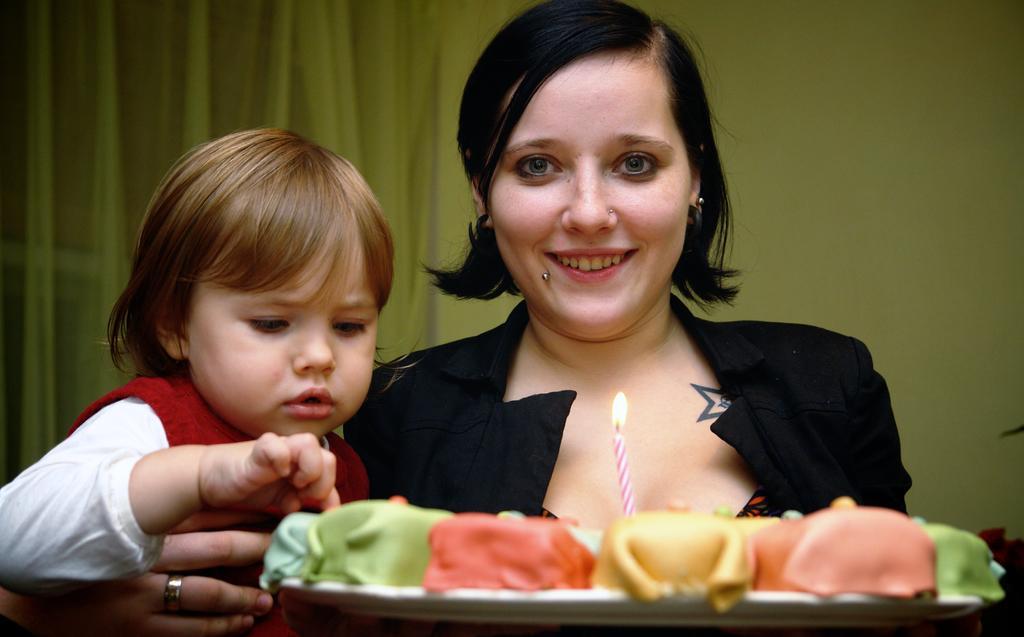In one or two sentences, can you explain what this image depicts? In the foreground, I can see two persons and a plate in which food items and a candle is there. In the background, I can see a wall and curtains. This image is taken, maybe in a room. 